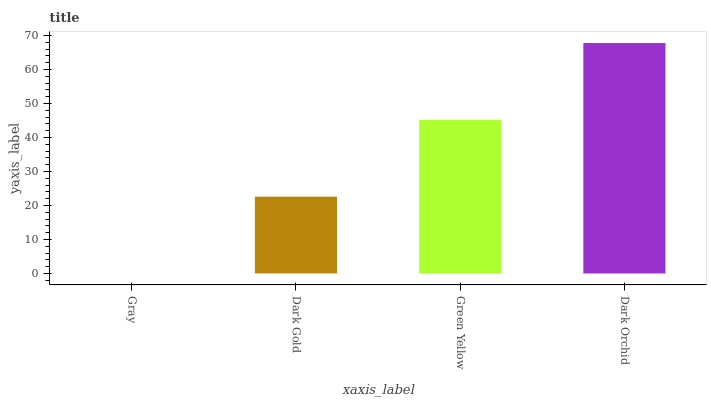Is Gray the minimum?
Answer yes or no. Yes. Is Dark Orchid the maximum?
Answer yes or no. Yes. Is Dark Gold the minimum?
Answer yes or no. No. Is Dark Gold the maximum?
Answer yes or no. No. Is Dark Gold greater than Gray?
Answer yes or no. Yes. Is Gray less than Dark Gold?
Answer yes or no. Yes. Is Gray greater than Dark Gold?
Answer yes or no. No. Is Dark Gold less than Gray?
Answer yes or no. No. Is Green Yellow the high median?
Answer yes or no. Yes. Is Dark Gold the low median?
Answer yes or no. Yes. Is Dark Gold the high median?
Answer yes or no. No. Is Dark Orchid the low median?
Answer yes or no. No. 